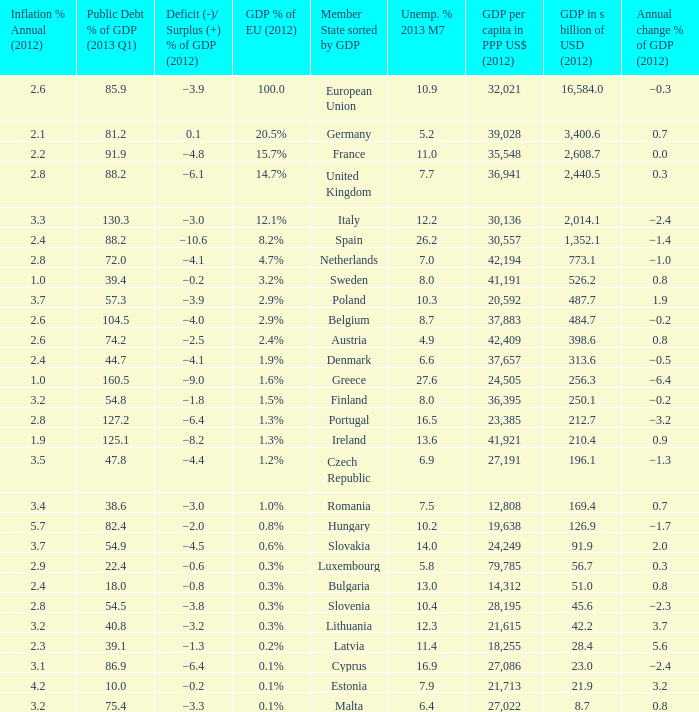What is the GDP % of EU in 2012 of the country with a GDP in billions of USD in 2012 of 256.3? 1.6%. 